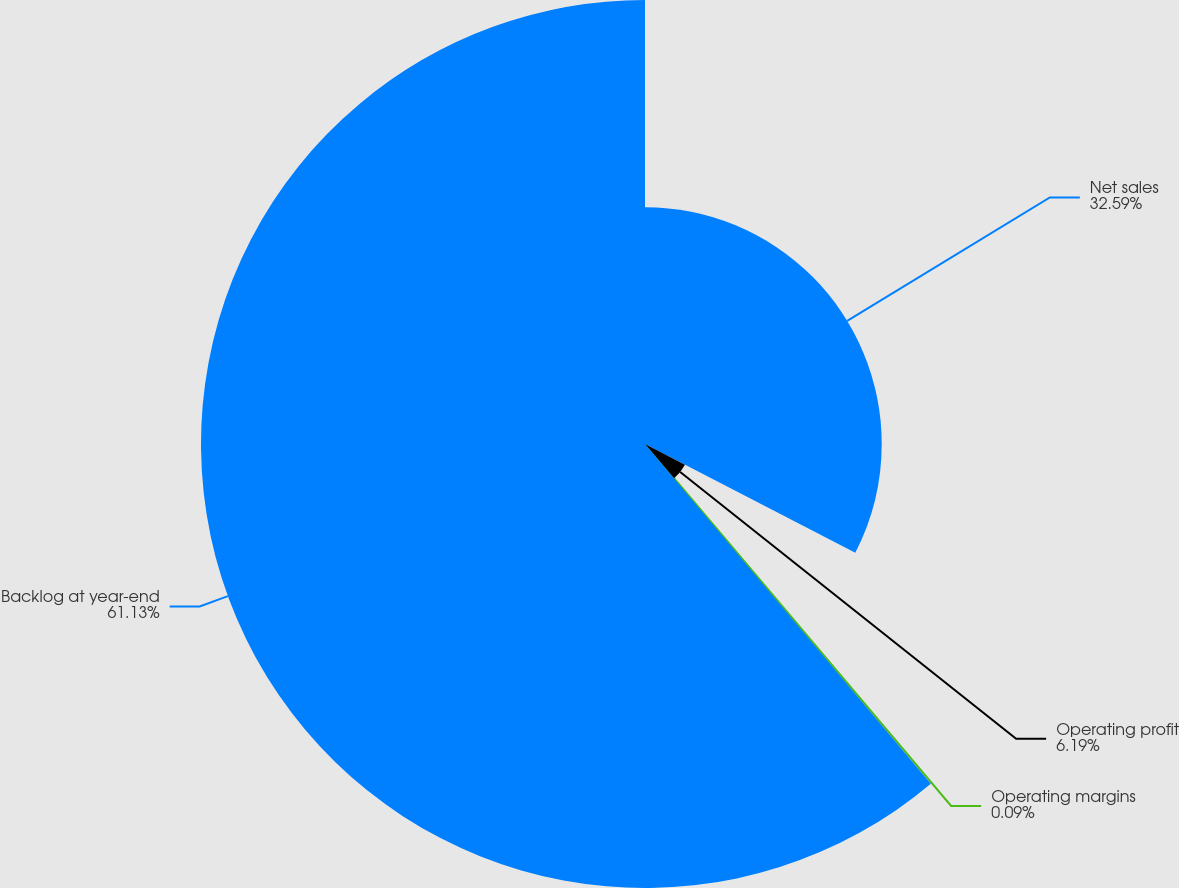Convert chart to OTSL. <chart><loc_0><loc_0><loc_500><loc_500><pie_chart><fcel>Net sales<fcel>Operating profit<fcel>Operating margins<fcel>Backlog at year-end<nl><fcel>32.59%<fcel>6.19%<fcel>0.09%<fcel>61.13%<nl></chart> 